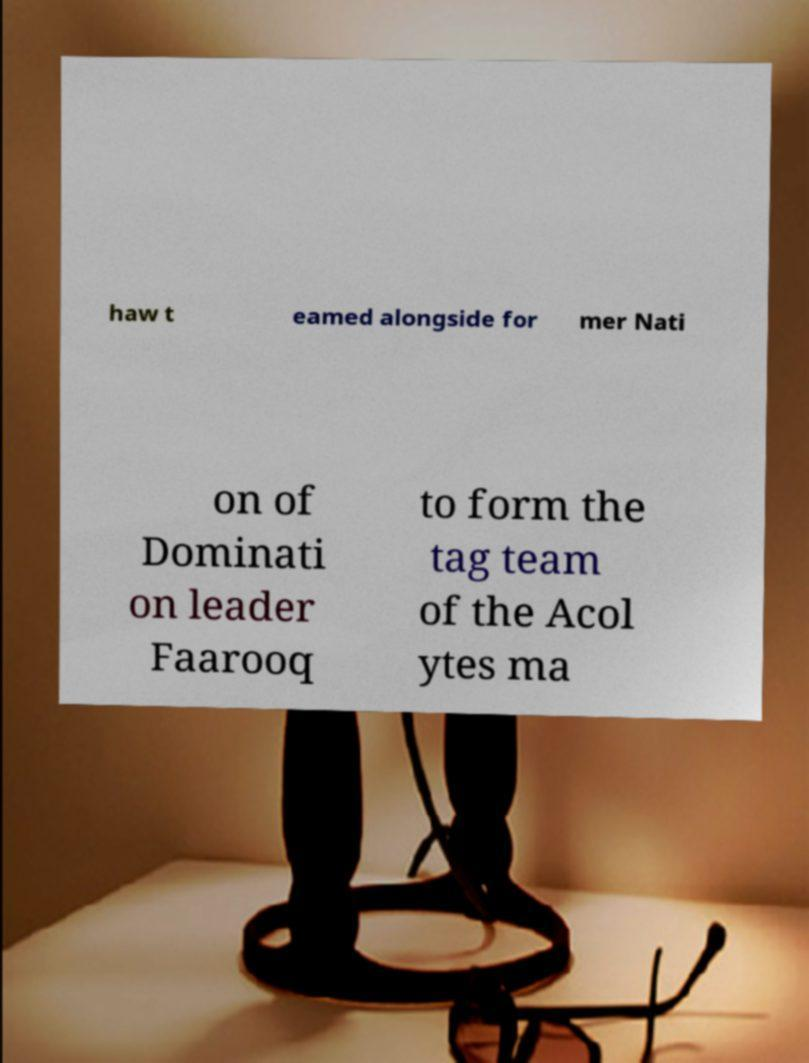Could you extract and type out the text from this image? haw t eamed alongside for mer Nati on of Dominati on leader Faarooq to form the tag team of the Acol ytes ma 